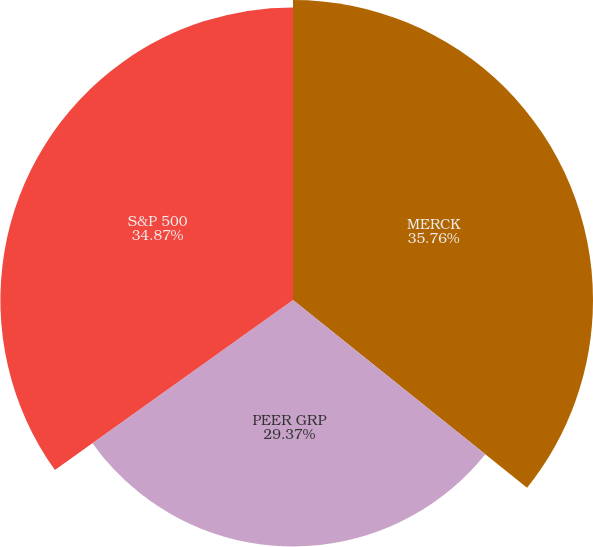Convert chart to OTSL. <chart><loc_0><loc_0><loc_500><loc_500><pie_chart><fcel>MERCK<fcel>PEER GRP<fcel>S&P 500<nl><fcel>35.75%<fcel>29.37%<fcel>34.87%<nl></chart> 